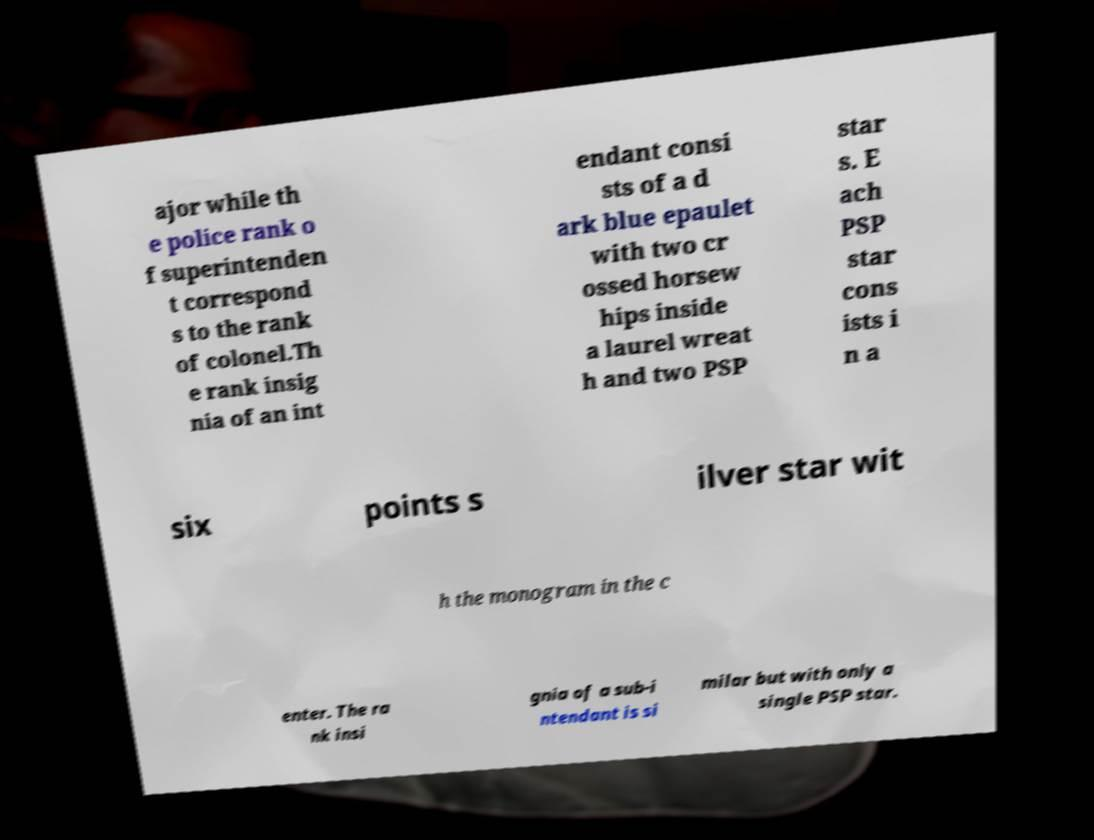Can you accurately transcribe the text from the provided image for me? ajor while th e police rank o f superintenden t correspond s to the rank of colonel.Th e rank insig nia of an int endant consi sts of a d ark blue epaulet with two cr ossed horsew hips inside a laurel wreat h and two PSP star s. E ach PSP star cons ists i n a six points s ilver star wit h the monogram in the c enter. The ra nk insi gnia of a sub-i ntendant is si milar but with only a single PSP star. 